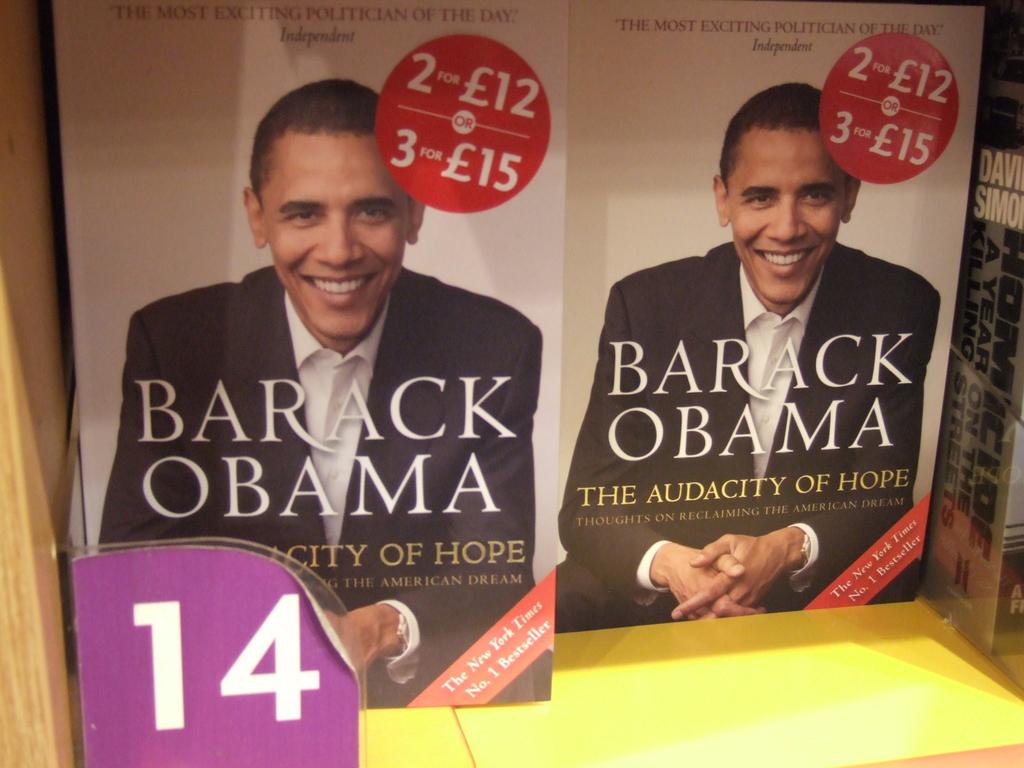What kind of dream is reclaimed?
Ensure brevity in your answer.  The american dream. 